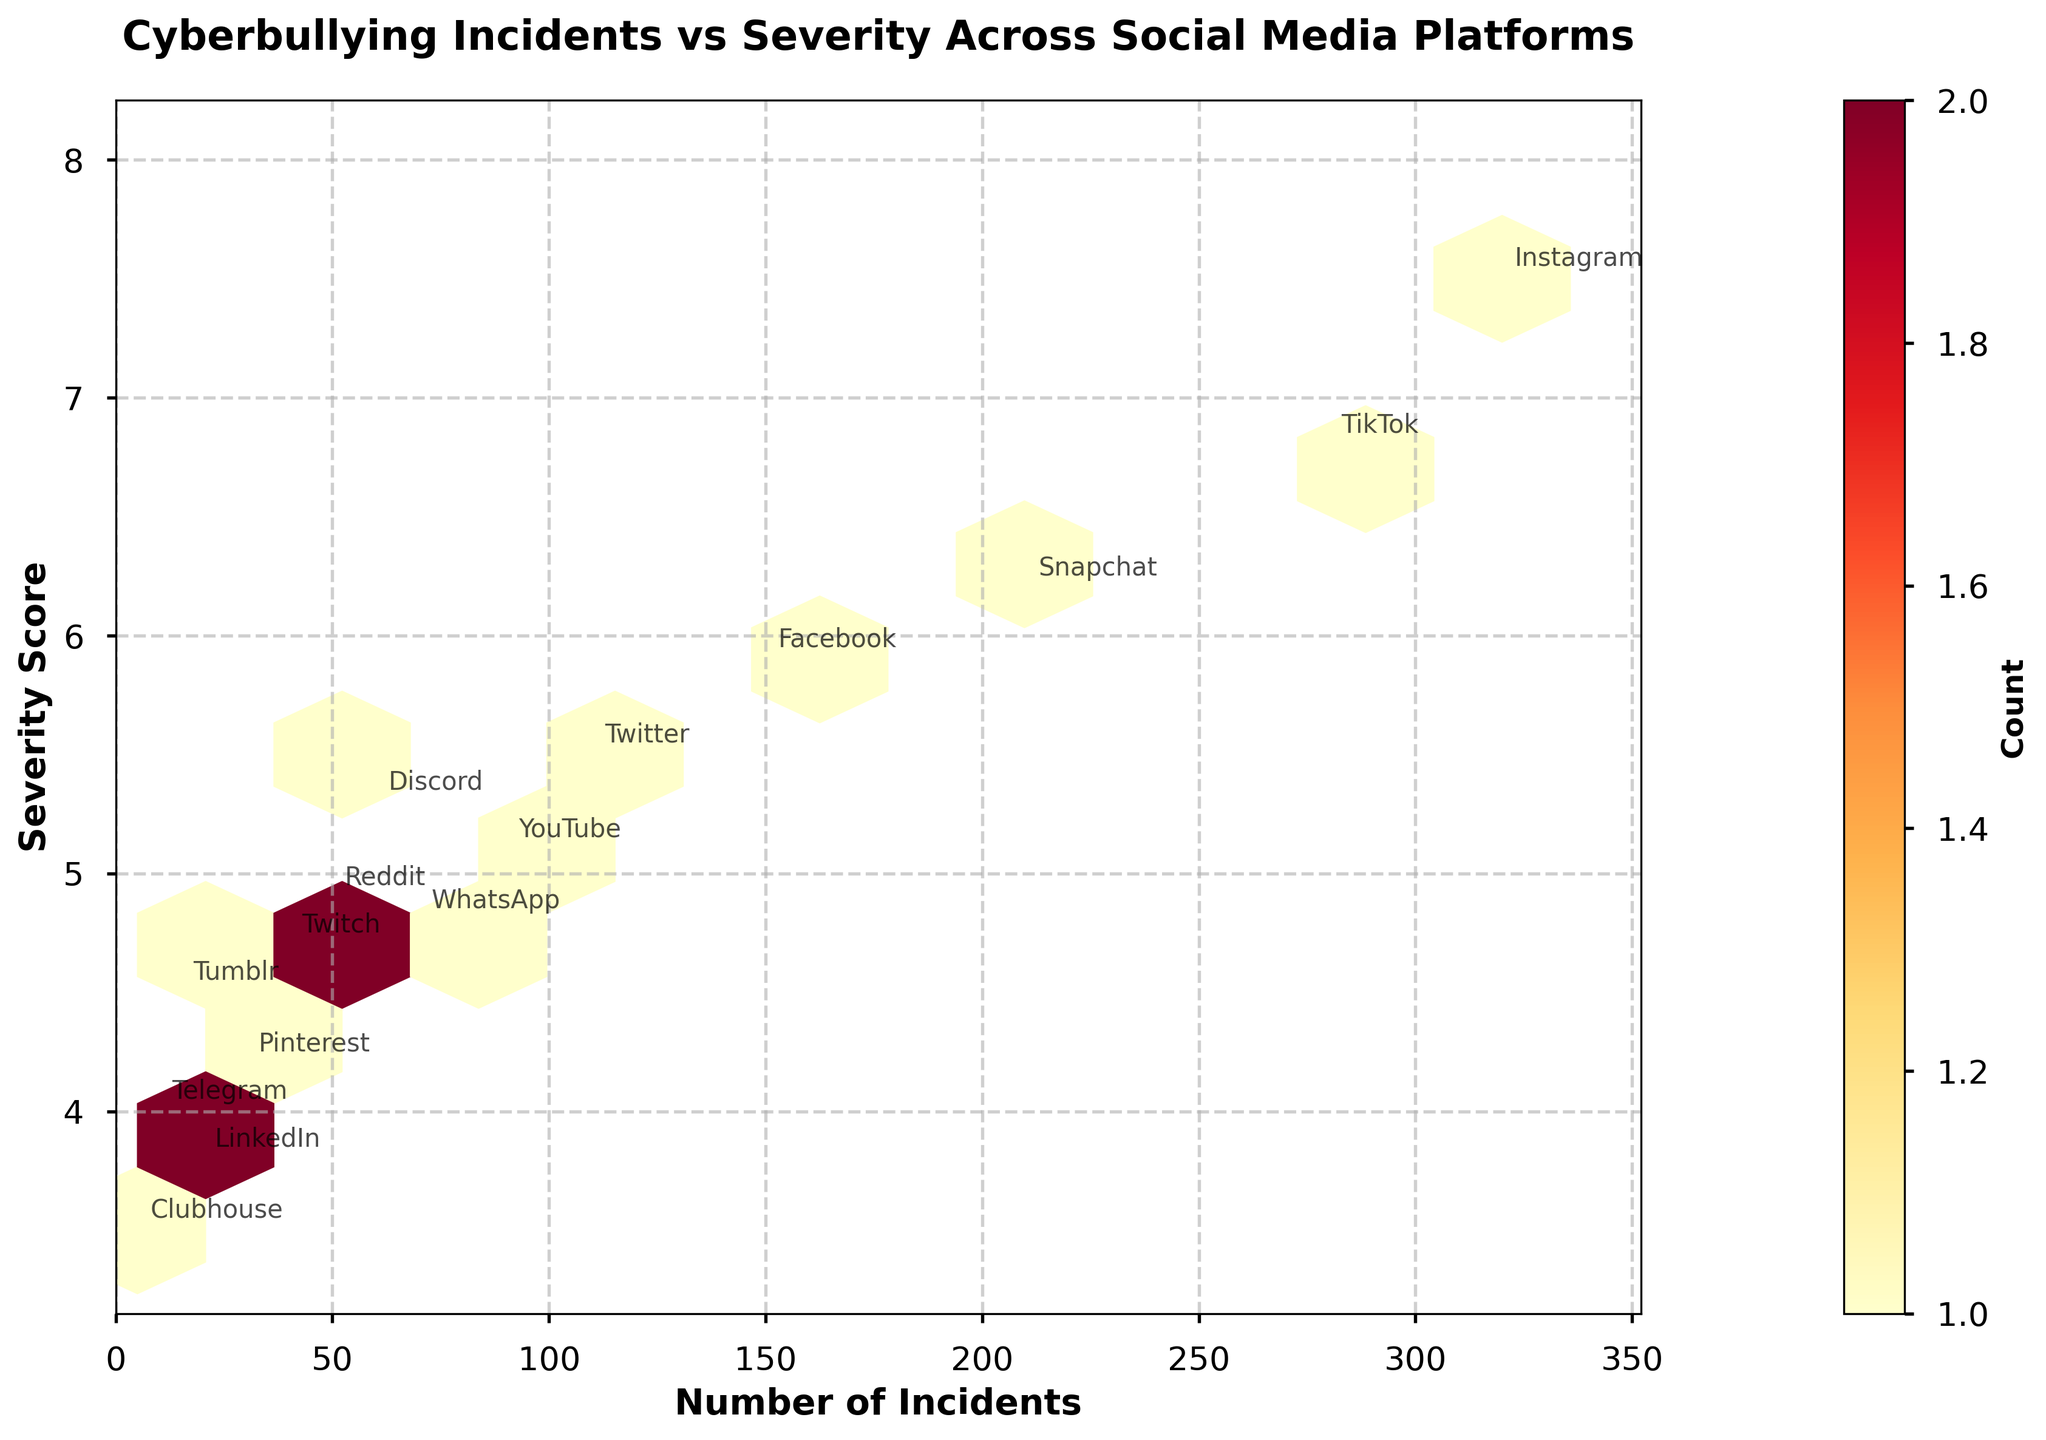How many social media platforms are included in the plot? To find the number of social media platforms, count the number of unique labels for the platforms in the plot. There are 15 platforms mentioned in the data set, which should also be annotated in the figure.
Answer: 15 What does the color intensity in the hexagons represent? The color intensity in the hexagons represents the count of data points (incidents) in that area. Darker colors indicate higher counts, while lighter colors indicate fewer counts. This can be confirmed by looking at the color bar labeled "Count."
Answer: Count of incidents Which platform has the highest number of incidents reported? By examining the plot, look for the platform with the highest x-value, representing the number of incidents. Instagram has the highest number of incidents at 320.
Answer: Instagram Which platform has the lowest severity score? By examining the plot for the smallest y-value, identify the platform associated with that point. Clubhouse has the lowest severity score at 3.5.
Answer: Clubhouse Which platform shows a relatively high number of incidents but with moderate severity? The plot reveals that Facebook has 150 incidents (a relatively high number) with a moderate severity of 5.9 when looking at both the x and y values.
Answer: Facebook What is the range of the number of incidents reported? To determine the range, subtract the smallest x-value from the largest x-value of the incidents. The smallest number is 5 (Clubhouse), and the largest is 320 (Instagram), resulting in a range of 320 - 5 = 315.
Answer: 315 Which social media platforms are clustered together in terms of incidents and severity? Identify the platforms that are close to each other on the plot both in terms of horizontal (incidents) and vertical (severity) positioning. WhatsApp (70 incidents, 4.8 severity), Discord (60 incidents, 5.3 severity), and Reddit (50 incidents, 4.9 severity) form a cluster.
Answer: WhatsApp, Discord, Reddit Between Instagram and TikTok, which platform has higher severity on average? By comparing the y-values (severity scores), Instagram has a severity score of 7.5, and TikTok has a severity score of 6.8. Thus, Instagram has a higher severity score compared to TikTok.
Answer: Instagram What can be deduced about the relationship between the frequency of incidents and severity? When looking at the scatter of points, it shows that platforms with higher numbers of incidents, like Instagram and TikTok, also tend to have higher severity scores. This could suggest a potential relationship where more frequent incidents could be more severe.
Answer: Higher frequency, higher severity What does the title of the plot indicate about the data presented? The title "Cyberbullying Incidents vs Severity Across Social Media Platforms" specifies that the plot is showing the relationship between the number of reported cyberbullying incidents and the severity of these incidents across various social media platforms.
Answer: Relationship between incidents and severity 